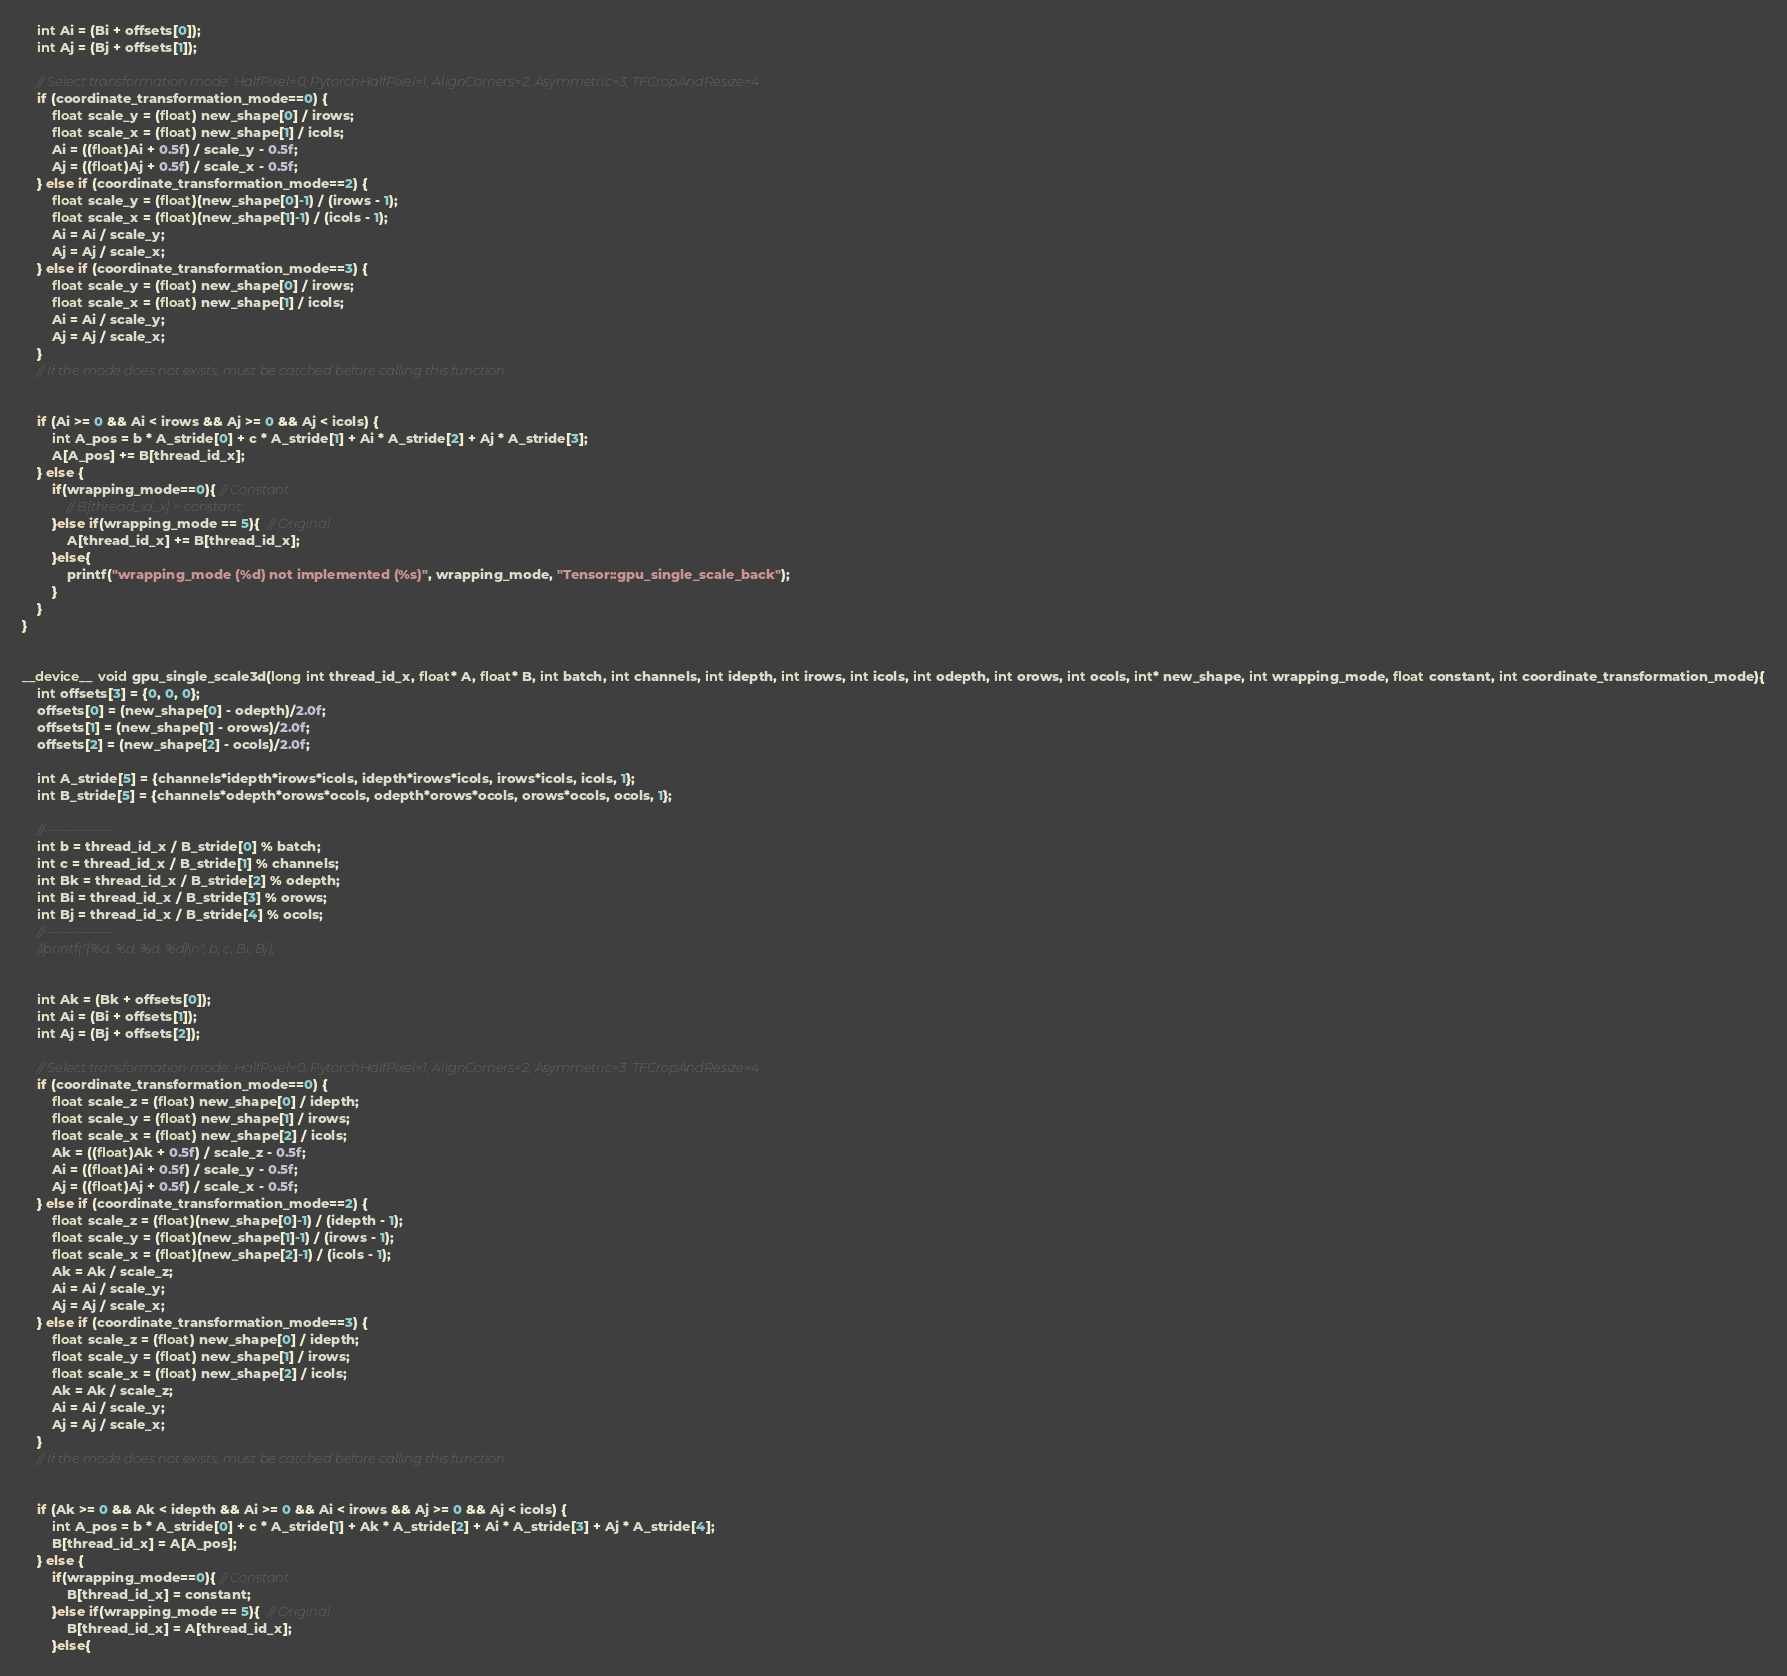Convert code to text. <code><loc_0><loc_0><loc_500><loc_500><_Cuda_>

    int Ai = (Bi + offsets[0]);
    int Aj = (Bj + offsets[1]);

    // Select transformation mode: HalfPixel=0, PytorchHalfPixel=1, AlignCorners=2, Asymmetric=3, TFCropAndResize=4
    if (coordinate_transformation_mode==0) {
        float scale_y = (float) new_shape[0] / irows;
        float scale_x = (float) new_shape[1] / icols;
        Ai = ((float)Ai + 0.5f) / scale_y - 0.5f;
        Aj = ((float)Aj + 0.5f) / scale_x - 0.5f;
    } else if (coordinate_transformation_mode==2) {
        float scale_y = (float)(new_shape[0]-1) / (irows - 1);
        float scale_x = (float)(new_shape[1]-1) / (icols - 1);
        Ai = Ai / scale_y;
        Aj = Aj / scale_x;
    } else if (coordinate_transformation_mode==3) {
        float scale_y = (float) new_shape[0] / irows;
        float scale_x = (float) new_shape[1] / icols;
        Ai = Ai / scale_y;
        Aj = Aj / scale_x;
    }
    // If the mode does not exists, must be catched before calling this function


    if (Ai >= 0 && Ai < irows && Aj >= 0 && Aj < icols) {
        int A_pos = b * A_stride[0] + c * A_stride[1] + Ai * A_stride[2] + Aj * A_stride[3];
        A[A_pos] += B[thread_id_x];
    } else {
        if(wrapping_mode==0){ // Constant
            // B[thread_id_x] = constant;
        }else if(wrapping_mode == 5){  // Original
            A[thread_id_x] += B[thread_id_x];
        }else{
            printf("wrapping_mode (%d) not implemented (%s)", wrapping_mode, "Tensor::gpu_single_scale_back");
        }
    }
}


__device__ void gpu_single_scale3d(long int thread_id_x, float* A, float* B, int batch, int channels, int idepth, int irows, int icols, int odepth, int orows, int ocols, int* new_shape, int wrapping_mode, float constant, int coordinate_transformation_mode){
    int offsets[3] = {0, 0, 0};
    offsets[0] = (new_shape[0] - odepth)/2.0f;
    offsets[1] = (new_shape[1] - orows)/2.0f;
    offsets[2] = (new_shape[2] - ocols)/2.0f;

    int A_stride[5] = {channels*idepth*irows*icols, idepth*irows*icols, irows*icols, icols, 1};
    int B_stride[5] = {channels*odepth*orows*ocols, odepth*orows*ocols, orows*ocols, ocols, 1};

    //--------------
    int b = thread_id_x / B_stride[0] % batch;
    int c = thread_id_x / B_stride[1] % channels;
    int Bk = thread_id_x / B_stride[2] % odepth;
    int Bi = thread_id_x / B_stride[3] % orows;
    int Bj = thread_id_x / B_stride[4] % ocols;
    //--------------
    //printf("{%d, %d, %d, %d}\n", b, c, Bi, Bj);


    int Ak = (Bk + offsets[0]);
    int Ai = (Bi + offsets[1]);
    int Aj = (Bj + offsets[2]);

    // Select transformation mode: HalfPixel=0, PytorchHalfPixel=1, AlignCorners=2, Asymmetric=3, TFCropAndResize=4
    if (coordinate_transformation_mode==0) {
        float scale_z = (float) new_shape[0] / idepth;
        float scale_y = (float) new_shape[1] / irows;
        float scale_x = (float) new_shape[2] / icols;
        Ak = ((float)Ak + 0.5f) / scale_z - 0.5f;
        Ai = ((float)Ai + 0.5f) / scale_y - 0.5f;
        Aj = ((float)Aj + 0.5f) / scale_x - 0.5f;
    } else if (coordinate_transformation_mode==2) {
        float scale_z = (float)(new_shape[0]-1) / (idepth - 1);
        float scale_y = (float)(new_shape[1]-1) / (irows - 1);
        float scale_x = (float)(new_shape[2]-1) / (icols - 1);
        Ak = Ak / scale_z;
        Ai = Ai / scale_y;
        Aj = Aj / scale_x;
    } else if (coordinate_transformation_mode==3) {
        float scale_z = (float) new_shape[0] / idepth;
        float scale_y = (float) new_shape[1] / irows;
        float scale_x = (float) new_shape[2] / icols;
        Ak = Ak / scale_z;
        Ai = Ai / scale_y;
        Aj = Aj / scale_x;
    }
    // If the mode does not exists, must be catched before calling this function


    if (Ak >= 0 && Ak < idepth && Ai >= 0 && Ai < irows && Aj >= 0 && Aj < icols) {
        int A_pos = b * A_stride[0] + c * A_stride[1] + Ak * A_stride[2] + Ai * A_stride[3] + Aj * A_stride[4];
        B[thread_id_x] = A[A_pos];
    } else {
        if(wrapping_mode==0){ // Constant
            B[thread_id_x] = constant;
        }else if(wrapping_mode == 5){  // Original
            B[thread_id_x] = A[thread_id_x];
        }else{</code> 